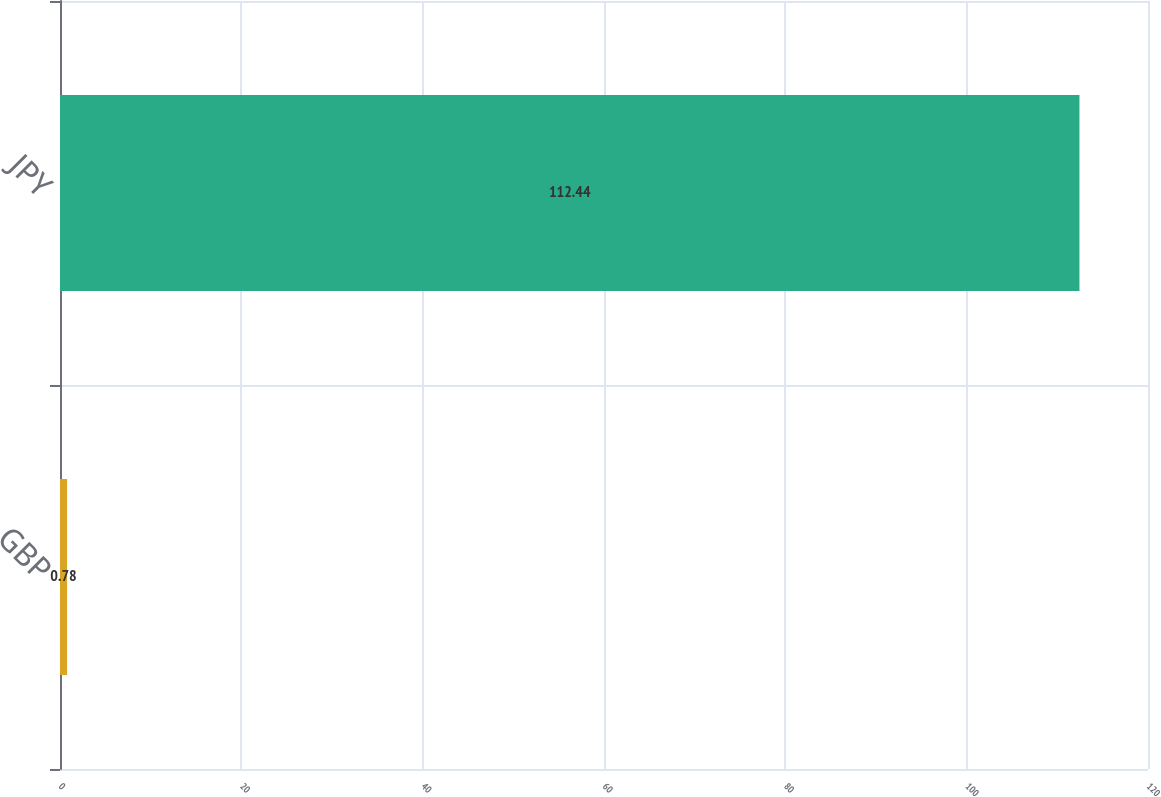<chart> <loc_0><loc_0><loc_500><loc_500><bar_chart><fcel>GBP<fcel>JPY<nl><fcel>0.78<fcel>112.44<nl></chart> 